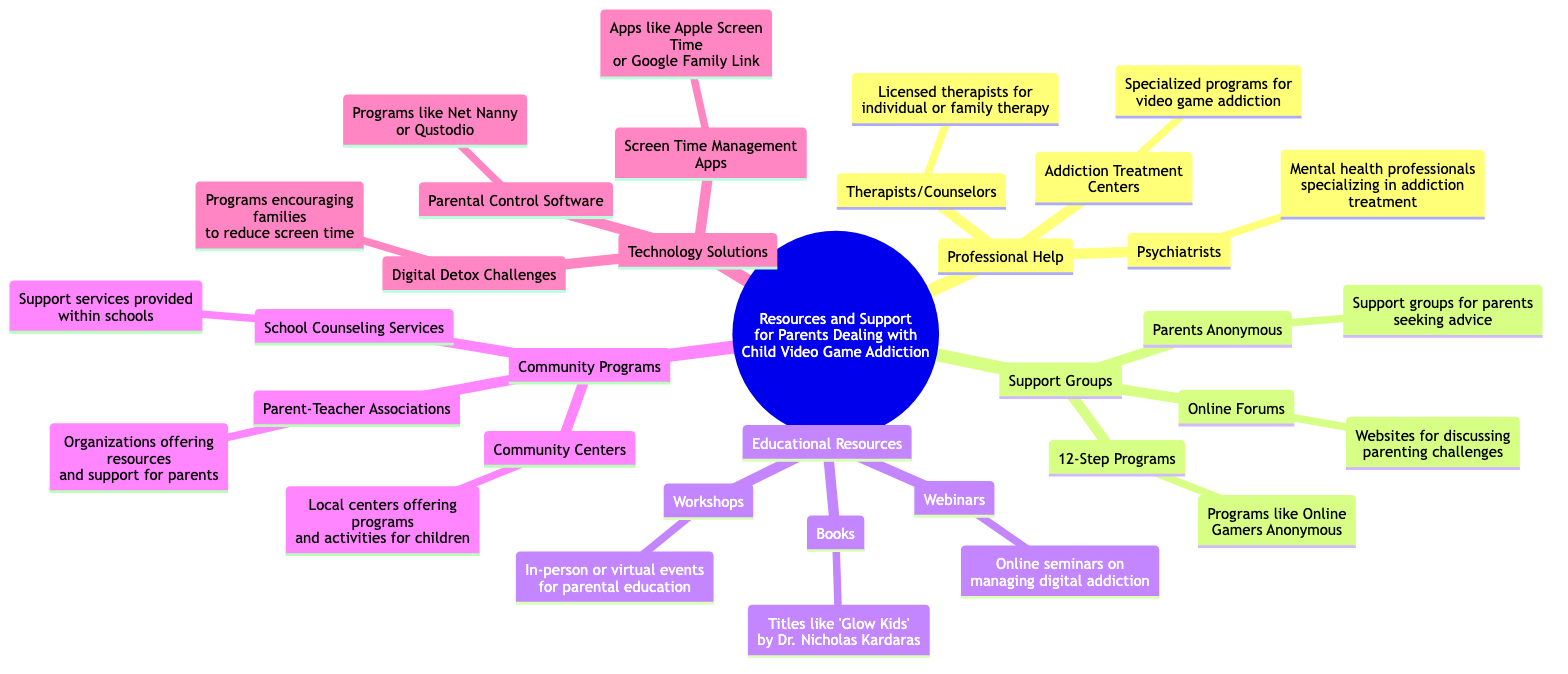What is the central topic of the diagram? The central topic is explicitly labeled and clear from the diagram's root node, which states "Resources and Support for Parents Dealing with Child Video Game Addiction."
Answer: Resources and Support for Parents Dealing with Child Video Game Addiction How many subtopics are included in the diagram? The diagram presents five subtopics branching from the central topic. By counting the subtopics, we find Professional Help, Support Groups, Educational Resources, Community Programs, and Technology Solutions.
Answer: 5 What is one type of professional help mentioned? The diagram lists various types of professional help under the designated category. Among the listed resources, "Psychiatrists" is one specific type mentioned.
Answer: Psychiatrists Which support group discusses sharing experiences among parents? The diagram indicates that "Parents Anonymous" is specifically focused on providing a space for parents to seek advice and share experiences.
Answer: Parents Anonymous What is a resource available in Educational Resources? The diagram includes multiple resources within the Educational Resources category, such as "Books." This is a clear representation of what is available for parents seeking information.
Answer: Books Name a community program that offers local activities for children. Reviewing the Community Programs section, we see "Community Centers," which provides programs and activities for children in the local area.
Answer: Community Centers What is one technology solution listed for managing game time? In the Technology Solutions category, several options are mentioned; one of these is "Parental Control Software." This indicates a tool parents might use to manage gaming.
Answer: Parental Control Software Which subgroup is specifically modeled after Alcoholics Anonymous? The diagram specifies that "12-Step Programs" are modeled after Alcoholics Anonymous and includes programs like Online Gamers Anonymous.
Answer: 12-Step Programs Which Educational Resource category provides online seminars? The diagram explicitly states that "Webinars" are one of the resources available within the Educational Resources subtopic, which are described as online seminars on managing digital addiction.
Answer: Webinars 